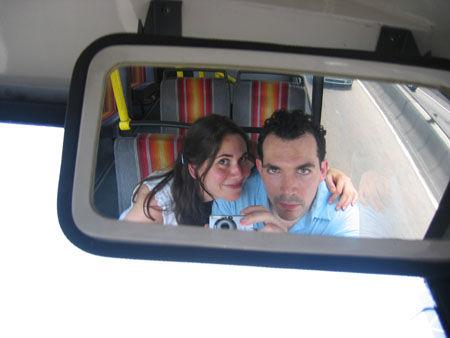Is this person have a camera?
Answer briefly. Yes. Where was the picture taken?
Write a very short answer. Bus. How many people are visible?
Short answer required. 2. What are  the people looking at?
Answer briefly. Mirror. What is the woman doing?
Answer briefly. Smiling. Where is the animal located?
Keep it brief. Nowhere. Is the man taking a picture of himself?
Be succinct. Yes. 